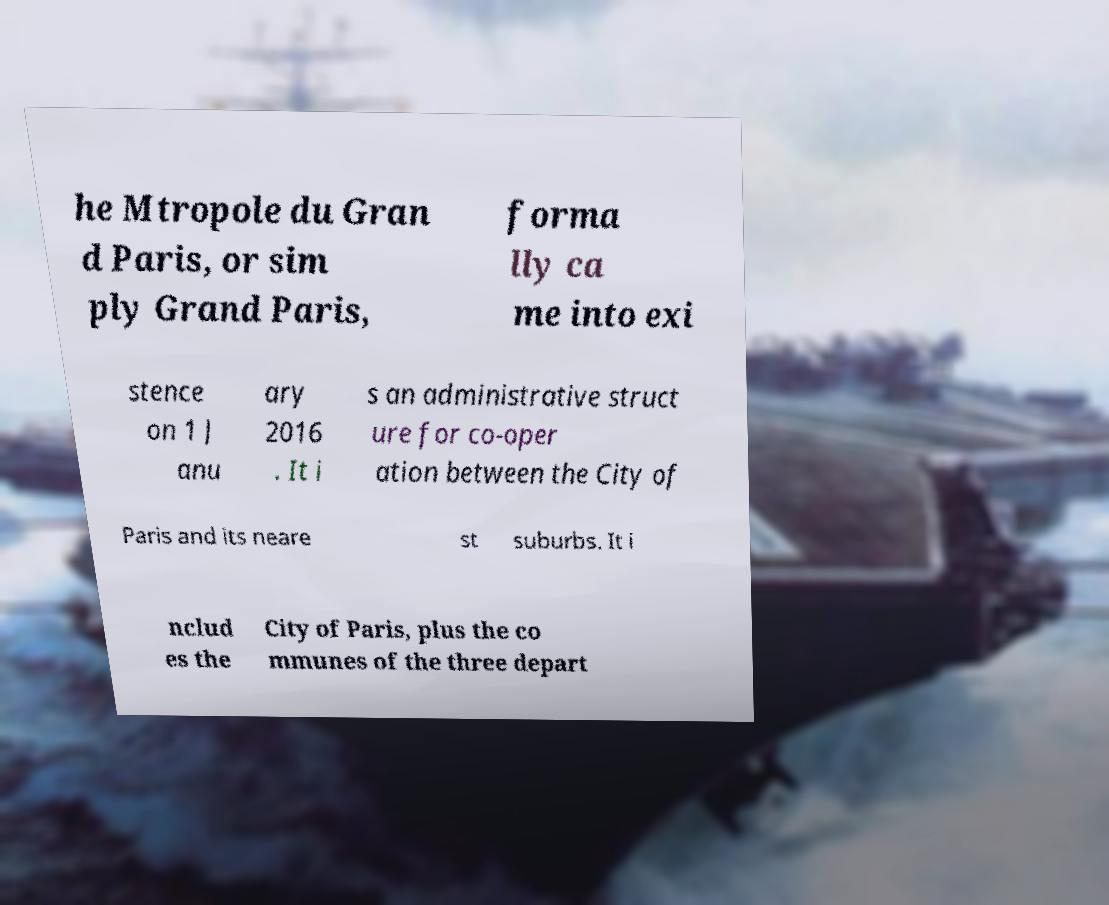There's text embedded in this image that I need extracted. Can you transcribe it verbatim? he Mtropole du Gran d Paris, or sim ply Grand Paris, forma lly ca me into exi stence on 1 J anu ary 2016 . It i s an administrative struct ure for co-oper ation between the City of Paris and its neare st suburbs. It i nclud es the City of Paris, plus the co mmunes of the three depart 